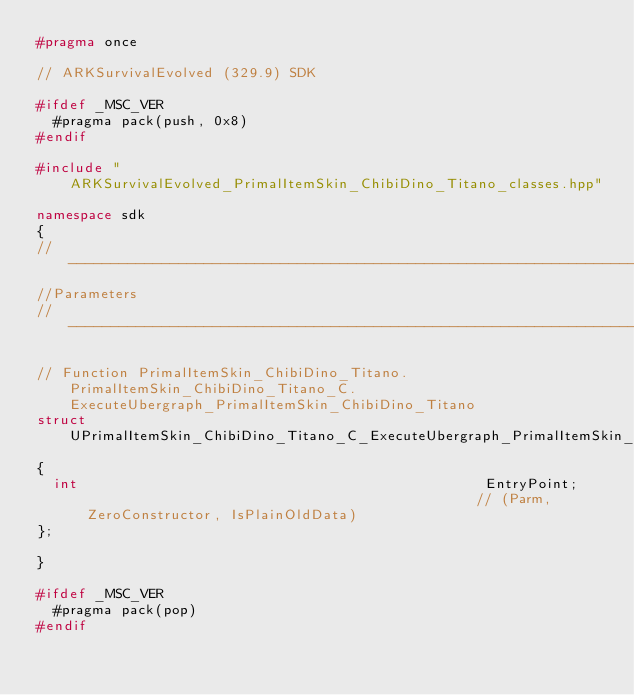<code> <loc_0><loc_0><loc_500><loc_500><_C++_>#pragma once

// ARKSurvivalEvolved (329.9) SDK

#ifdef _MSC_VER
	#pragma pack(push, 0x8)
#endif

#include "ARKSurvivalEvolved_PrimalItemSkin_ChibiDino_Titano_classes.hpp"

namespace sdk
{
//---------------------------------------------------------------------------
//Parameters
//---------------------------------------------------------------------------

// Function PrimalItemSkin_ChibiDino_Titano.PrimalItemSkin_ChibiDino_Titano_C.ExecuteUbergraph_PrimalItemSkin_ChibiDino_Titano
struct UPrimalItemSkin_ChibiDino_Titano_C_ExecuteUbergraph_PrimalItemSkin_ChibiDino_Titano_Params
{
	int                                                EntryPoint;                                               // (Parm, ZeroConstructor, IsPlainOldData)
};

}

#ifdef _MSC_VER
	#pragma pack(pop)
#endif
</code> 